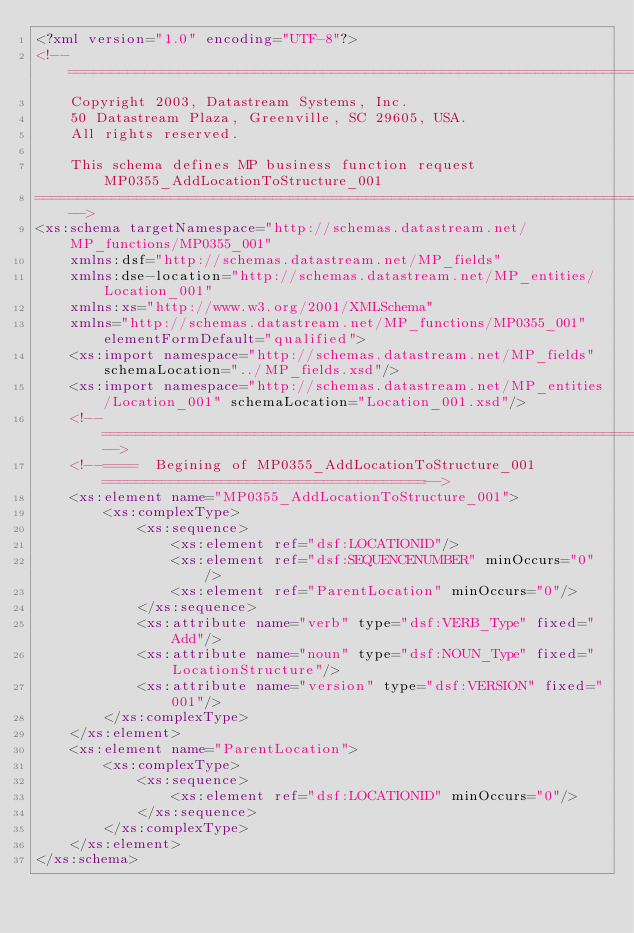Convert code to text. <code><loc_0><loc_0><loc_500><loc_500><_XML_><?xml version="1.0" encoding="UTF-8"?>
<!-- ================================================================================
	Copyright 2003, Datastream Systems, Inc.
	50 Datastream Plaza, Greenville, SC 29605, USA.
	All rights reserved.
	
	This schema defines MP business function request MP0355_AddLocationToStructure_001
==================================================================================-->  
<xs:schema targetNamespace="http://schemas.datastream.net/MP_functions/MP0355_001" 
	xmlns:dsf="http://schemas.datastream.net/MP_fields" 
	xmlns:dse-location="http://schemas.datastream.net/MP_entities/Location_001"
	xmlns:xs="http://www.w3.org/2001/XMLSchema" 
	xmlns="http://schemas.datastream.net/MP_functions/MP0355_001" elementFormDefault="qualified">
	<xs:import namespace="http://schemas.datastream.net/MP_fields" schemaLocation="../MP_fields.xsd"/>
	<xs:import namespace="http://schemas.datastream.net/MP_entities/Location_001" schemaLocation="Location_001.xsd"/>	
	<!--===============================================================================-->
	<!--====  Begining of MP0355_AddLocationToStructure_001 ======================================-->
	<xs:element name="MP0355_AddLocationToStructure_001">
		<xs:complexType>
			<xs:sequence>
				<xs:element ref="dsf:LOCATIONID"/>
				<xs:element ref="dsf:SEQUENCENUMBER" minOccurs="0"/>
				<xs:element ref="ParentLocation" minOccurs="0"/>
			</xs:sequence>
			<xs:attribute name="verb" type="dsf:VERB_Type" fixed="Add"/>
			<xs:attribute name="noun" type="dsf:NOUN_Type" fixed="LocationStructure"/>
			<xs:attribute name="version" type="dsf:VERSION" fixed="001"/>
		</xs:complexType>
	</xs:element>
	<xs:element name="ParentLocation">
		<xs:complexType>
			<xs:sequence>
				<xs:element ref="dsf:LOCATIONID" minOccurs="0"/>
			</xs:sequence>
		</xs:complexType>
	</xs:element>
</xs:schema></code> 